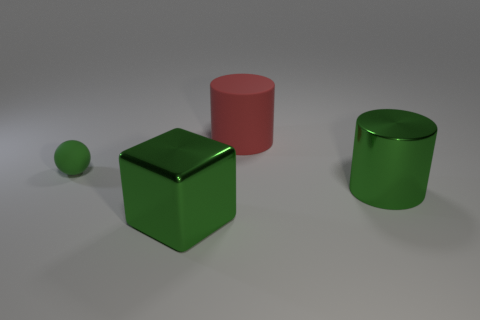Is there anything else that has the same size as the green sphere?
Give a very brief answer. No. There is a large green thing that is the same shape as the large red thing; what is its material?
Provide a succinct answer. Metal. What material is the big object that is in front of the large metal cylinder?
Provide a short and direct response. Metal. What material is the small sphere?
Offer a terse response. Rubber. The thing to the right of the cylinder that is behind the green thing that is to the right of the block is made of what material?
Your answer should be compact. Metal. Is there any other thing that has the same material as the block?
Provide a succinct answer. Yes. There is a red rubber object; does it have the same size as the metallic object that is on the left side of the green metal cylinder?
Your answer should be compact. Yes. What number of objects are matte things that are to the left of the green block or big objects behind the tiny green thing?
Keep it short and to the point. 2. What is the color of the rubber cylinder behind the small green thing?
Your answer should be very brief. Red. There is a big cylinder that is behind the green ball; is there a red thing left of it?
Provide a succinct answer. No. 